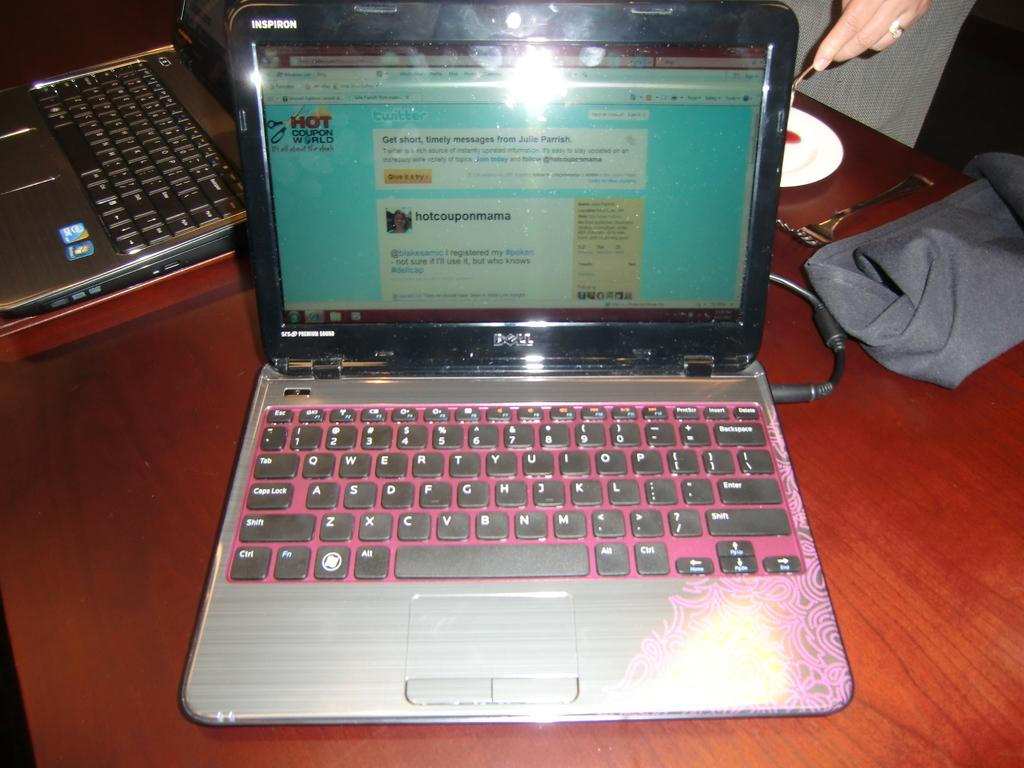<image>
Give a short and clear explanation of the subsequent image. A Dell laptop computer is open to a screen related to coupons. 